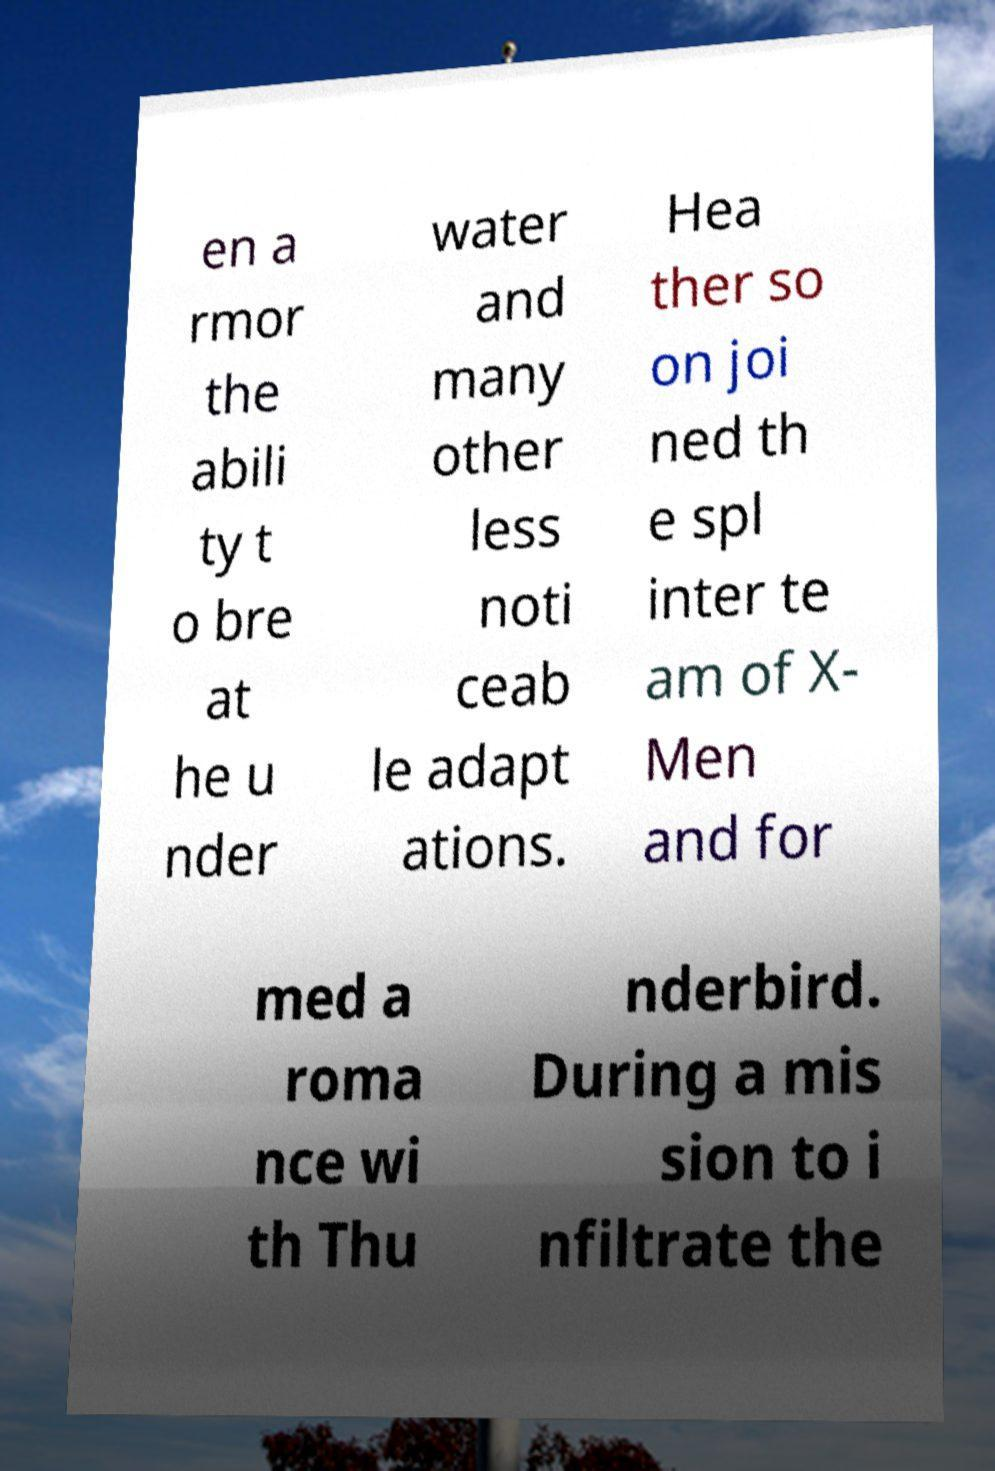Please identify and transcribe the text found in this image. en a rmor the abili ty t o bre at he u nder water and many other less noti ceab le adapt ations. Hea ther so on joi ned th e spl inter te am of X- Men and for med a roma nce wi th Thu nderbird. During a mis sion to i nfiltrate the 